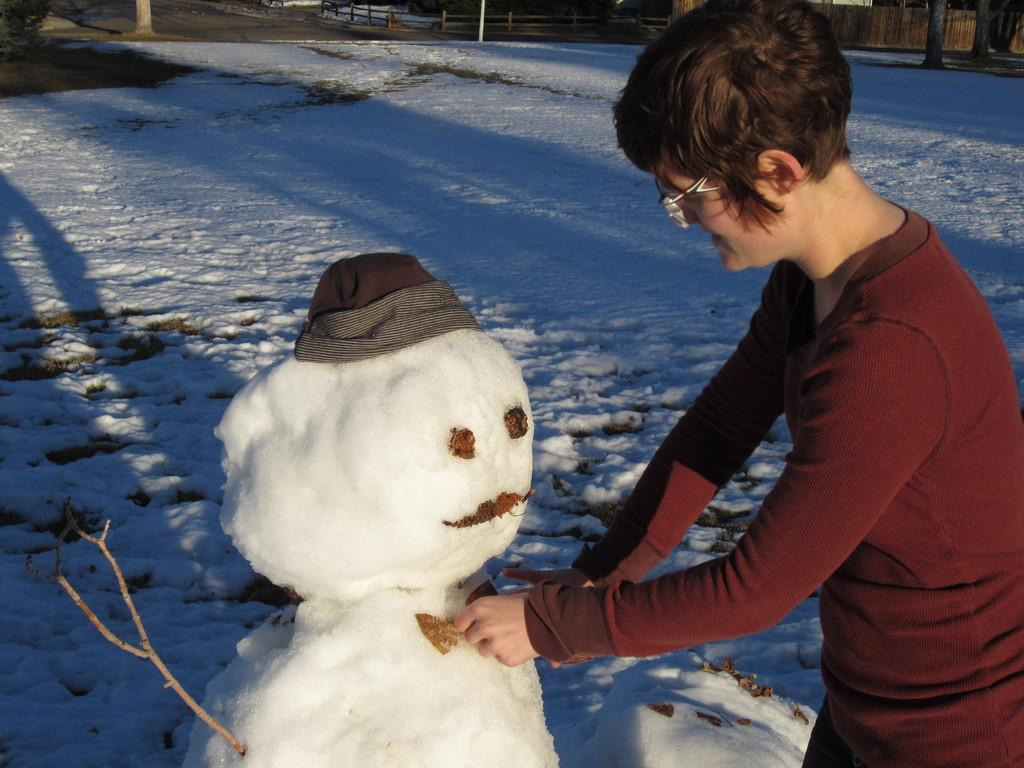Who is the main subject in the image? There is a woman in the image. What is the woman wearing? The woman is wearing a red dress. What is the weather like in the image? There is snow in the image, indicating a cold or wintery setting. What can be seen in the background of the image? There are trees, a railing, and other objects in the background of the image. What type of prose can be heard being read by the woman in the image? There is no indication in the image that the woman is reading or speaking any prose. In which direction is the woman facing in the image? The image does not provide enough information to determine the direction the woman is facing. 